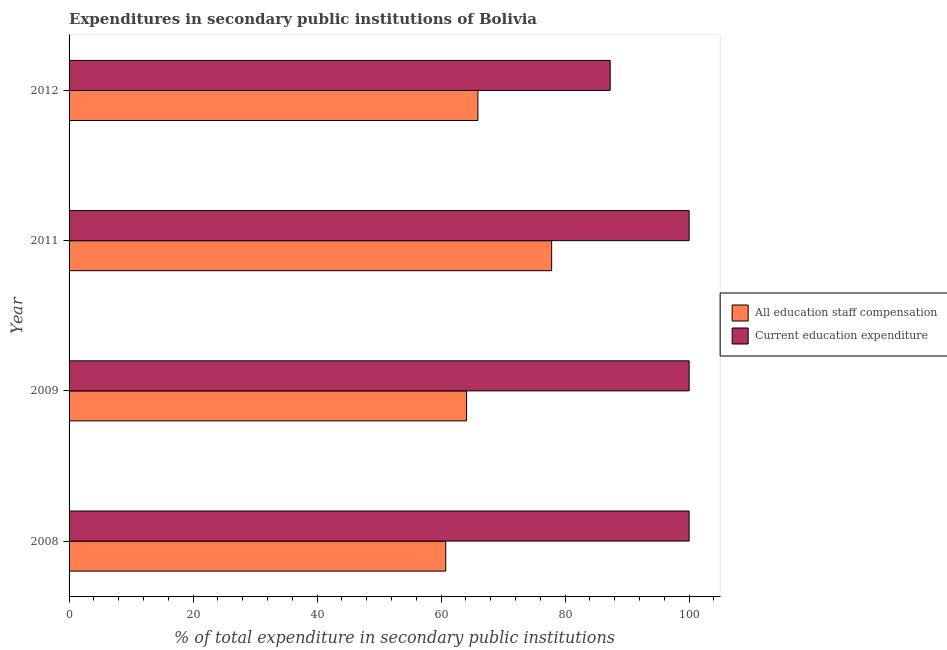Are the number of bars on each tick of the Y-axis equal?
Provide a short and direct response. Yes. How many bars are there on the 2nd tick from the bottom?
Ensure brevity in your answer.  2. What is the expenditure in education in 2008?
Keep it short and to the point. 100. Across all years, what is the maximum expenditure in staff compensation?
Your response must be concise. 77.83. Across all years, what is the minimum expenditure in staff compensation?
Your response must be concise. 60.75. What is the total expenditure in education in the graph?
Your answer should be very brief. 387.26. What is the difference between the expenditure in education in 2009 and that in 2012?
Make the answer very short. 12.73. What is the difference between the expenditure in education in 2011 and the expenditure in staff compensation in 2008?
Give a very brief answer. 39.25. What is the average expenditure in education per year?
Offer a very short reply. 96.82. In the year 2008, what is the difference between the expenditure in staff compensation and expenditure in education?
Keep it short and to the point. -39.25. What is the ratio of the expenditure in staff compensation in 2009 to that in 2011?
Give a very brief answer. 0.82. Is the difference between the expenditure in education in 2008 and 2011 greater than the difference between the expenditure in staff compensation in 2008 and 2011?
Provide a short and direct response. Yes. What is the difference between the highest and the second highest expenditure in education?
Give a very brief answer. 0. What is the difference between the highest and the lowest expenditure in staff compensation?
Provide a short and direct response. 17.08. In how many years, is the expenditure in education greater than the average expenditure in education taken over all years?
Your answer should be compact. 3. What does the 1st bar from the top in 2011 represents?
Ensure brevity in your answer.  Current education expenditure. What does the 1st bar from the bottom in 2012 represents?
Your answer should be very brief. All education staff compensation. How many bars are there?
Your answer should be very brief. 8. What is the difference between two consecutive major ticks on the X-axis?
Offer a very short reply. 20. Are the values on the major ticks of X-axis written in scientific E-notation?
Give a very brief answer. No. Does the graph contain grids?
Keep it short and to the point. No. Where does the legend appear in the graph?
Give a very brief answer. Center right. How are the legend labels stacked?
Your answer should be very brief. Vertical. What is the title of the graph?
Offer a very short reply. Expenditures in secondary public institutions of Bolivia. What is the label or title of the X-axis?
Provide a succinct answer. % of total expenditure in secondary public institutions. What is the label or title of the Y-axis?
Your answer should be very brief. Year. What is the % of total expenditure in secondary public institutions of All education staff compensation in 2008?
Ensure brevity in your answer.  60.75. What is the % of total expenditure in secondary public institutions in Current education expenditure in 2008?
Give a very brief answer. 100. What is the % of total expenditure in secondary public institutions of All education staff compensation in 2009?
Offer a very short reply. 64.11. What is the % of total expenditure in secondary public institutions in All education staff compensation in 2011?
Provide a short and direct response. 77.83. What is the % of total expenditure in secondary public institutions of All education staff compensation in 2012?
Ensure brevity in your answer.  65.94. What is the % of total expenditure in secondary public institutions in Current education expenditure in 2012?
Give a very brief answer. 87.27. Across all years, what is the maximum % of total expenditure in secondary public institutions of All education staff compensation?
Your answer should be very brief. 77.83. Across all years, what is the maximum % of total expenditure in secondary public institutions of Current education expenditure?
Provide a succinct answer. 100. Across all years, what is the minimum % of total expenditure in secondary public institutions of All education staff compensation?
Give a very brief answer. 60.75. Across all years, what is the minimum % of total expenditure in secondary public institutions of Current education expenditure?
Provide a succinct answer. 87.27. What is the total % of total expenditure in secondary public institutions of All education staff compensation in the graph?
Provide a succinct answer. 268.61. What is the total % of total expenditure in secondary public institutions in Current education expenditure in the graph?
Keep it short and to the point. 387.26. What is the difference between the % of total expenditure in secondary public institutions of All education staff compensation in 2008 and that in 2009?
Your answer should be very brief. -3.36. What is the difference between the % of total expenditure in secondary public institutions in Current education expenditure in 2008 and that in 2009?
Give a very brief answer. -0. What is the difference between the % of total expenditure in secondary public institutions of All education staff compensation in 2008 and that in 2011?
Your answer should be very brief. -17.08. What is the difference between the % of total expenditure in secondary public institutions of Current education expenditure in 2008 and that in 2011?
Your response must be concise. -0. What is the difference between the % of total expenditure in secondary public institutions of All education staff compensation in 2008 and that in 2012?
Make the answer very short. -5.19. What is the difference between the % of total expenditure in secondary public institutions in Current education expenditure in 2008 and that in 2012?
Your answer should be very brief. 12.73. What is the difference between the % of total expenditure in secondary public institutions of All education staff compensation in 2009 and that in 2011?
Your response must be concise. -13.72. What is the difference between the % of total expenditure in secondary public institutions of Current education expenditure in 2009 and that in 2011?
Your response must be concise. 0. What is the difference between the % of total expenditure in secondary public institutions in All education staff compensation in 2009 and that in 2012?
Your response must be concise. -1.83. What is the difference between the % of total expenditure in secondary public institutions of Current education expenditure in 2009 and that in 2012?
Ensure brevity in your answer.  12.73. What is the difference between the % of total expenditure in secondary public institutions of All education staff compensation in 2011 and that in 2012?
Your answer should be very brief. 11.89. What is the difference between the % of total expenditure in secondary public institutions in Current education expenditure in 2011 and that in 2012?
Make the answer very short. 12.73. What is the difference between the % of total expenditure in secondary public institutions of All education staff compensation in 2008 and the % of total expenditure in secondary public institutions of Current education expenditure in 2009?
Your answer should be compact. -39.25. What is the difference between the % of total expenditure in secondary public institutions of All education staff compensation in 2008 and the % of total expenditure in secondary public institutions of Current education expenditure in 2011?
Ensure brevity in your answer.  -39.25. What is the difference between the % of total expenditure in secondary public institutions of All education staff compensation in 2008 and the % of total expenditure in secondary public institutions of Current education expenditure in 2012?
Provide a short and direct response. -26.52. What is the difference between the % of total expenditure in secondary public institutions of All education staff compensation in 2009 and the % of total expenditure in secondary public institutions of Current education expenditure in 2011?
Keep it short and to the point. -35.89. What is the difference between the % of total expenditure in secondary public institutions in All education staff compensation in 2009 and the % of total expenditure in secondary public institutions in Current education expenditure in 2012?
Offer a terse response. -23.16. What is the difference between the % of total expenditure in secondary public institutions of All education staff compensation in 2011 and the % of total expenditure in secondary public institutions of Current education expenditure in 2012?
Give a very brief answer. -9.44. What is the average % of total expenditure in secondary public institutions in All education staff compensation per year?
Give a very brief answer. 67.15. What is the average % of total expenditure in secondary public institutions of Current education expenditure per year?
Keep it short and to the point. 96.82. In the year 2008, what is the difference between the % of total expenditure in secondary public institutions of All education staff compensation and % of total expenditure in secondary public institutions of Current education expenditure?
Give a very brief answer. -39.25. In the year 2009, what is the difference between the % of total expenditure in secondary public institutions of All education staff compensation and % of total expenditure in secondary public institutions of Current education expenditure?
Offer a terse response. -35.89. In the year 2011, what is the difference between the % of total expenditure in secondary public institutions of All education staff compensation and % of total expenditure in secondary public institutions of Current education expenditure?
Make the answer very short. -22.17. In the year 2012, what is the difference between the % of total expenditure in secondary public institutions in All education staff compensation and % of total expenditure in secondary public institutions in Current education expenditure?
Provide a succinct answer. -21.33. What is the ratio of the % of total expenditure in secondary public institutions in All education staff compensation in 2008 to that in 2009?
Make the answer very short. 0.95. What is the ratio of the % of total expenditure in secondary public institutions in All education staff compensation in 2008 to that in 2011?
Give a very brief answer. 0.78. What is the ratio of the % of total expenditure in secondary public institutions of All education staff compensation in 2008 to that in 2012?
Keep it short and to the point. 0.92. What is the ratio of the % of total expenditure in secondary public institutions in Current education expenditure in 2008 to that in 2012?
Make the answer very short. 1.15. What is the ratio of the % of total expenditure in secondary public institutions of All education staff compensation in 2009 to that in 2011?
Provide a succinct answer. 0.82. What is the ratio of the % of total expenditure in secondary public institutions in All education staff compensation in 2009 to that in 2012?
Your answer should be compact. 0.97. What is the ratio of the % of total expenditure in secondary public institutions in Current education expenditure in 2009 to that in 2012?
Offer a terse response. 1.15. What is the ratio of the % of total expenditure in secondary public institutions in All education staff compensation in 2011 to that in 2012?
Give a very brief answer. 1.18. What is the ratio of the % of total expenditure in secondary public institutions of Current education expenditure in 2011 to that in 2012?
Your answer should be very brief. 1.15. What is the difference between the highest and the second highest % of total expenditure in secondary public institutions in All education staff compensation?
Keep it short and to the point. 11.89. What is the difference between the highest and the lowest % of total expenditure in secondary public institutions of All education staff compensation?
Keep it short and to the point. 17.08. What is the difference between the highest and the lowest % of total expenditure in secondary public institutions in Current education expenditure?
Your answer should be compact. 12.73. 